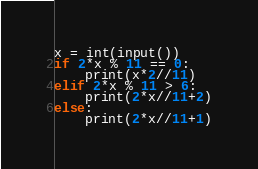Convert code to text. <code><loc_0><loc_0><loc_500><loc_500><_Python_>x = int(input())
if 2*x % 11 == 0:
    print(x*2//11)
elif 2*x % 11 > 6:
    print(2*x//11+2)
else:
    print(2*x//11+1)
</code> 